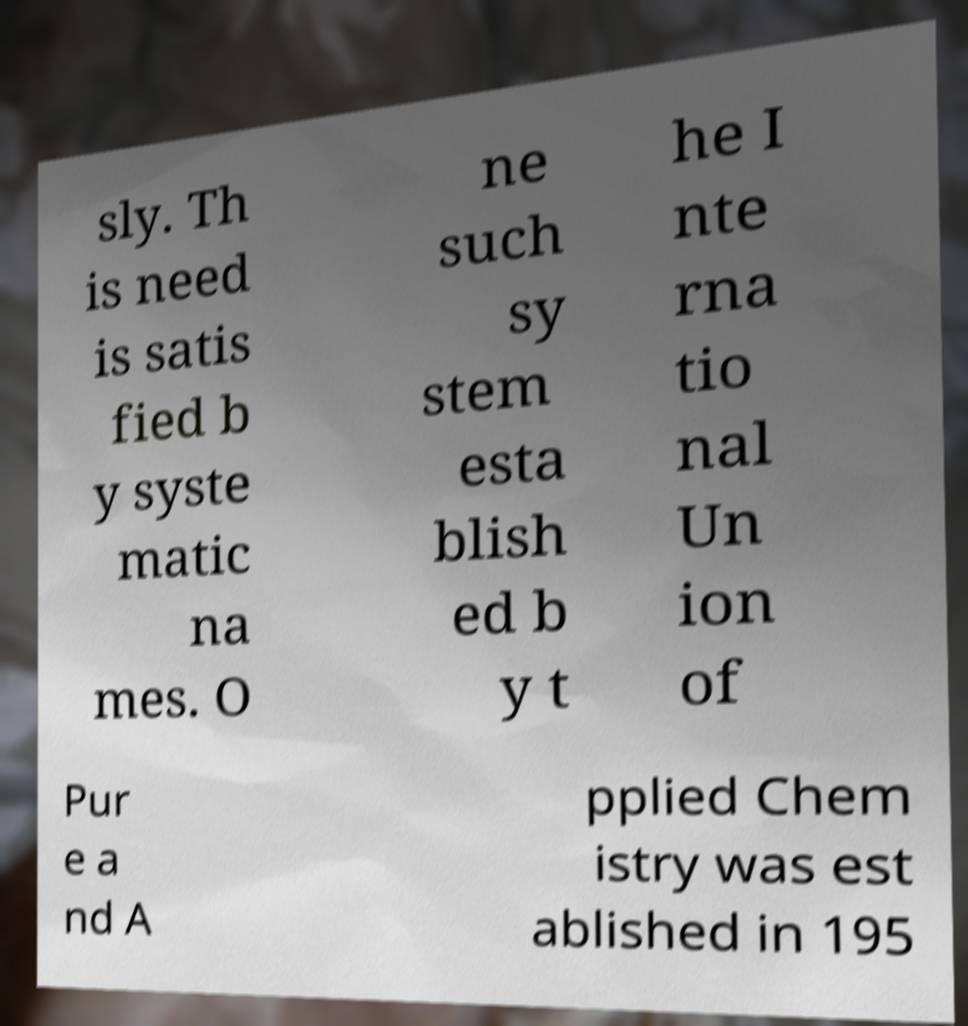Can you read and provide the text displayed in the image?This photo seems to have some interesting text. Can you extract and type it out for me? sly. Th is need is satis fied b y syste matic na mes. O ne such sy stem esta blish ed b y t he I nte rna tio nal Un ion of Pur e a nd A pplied Chem istry was est ablished in 195 